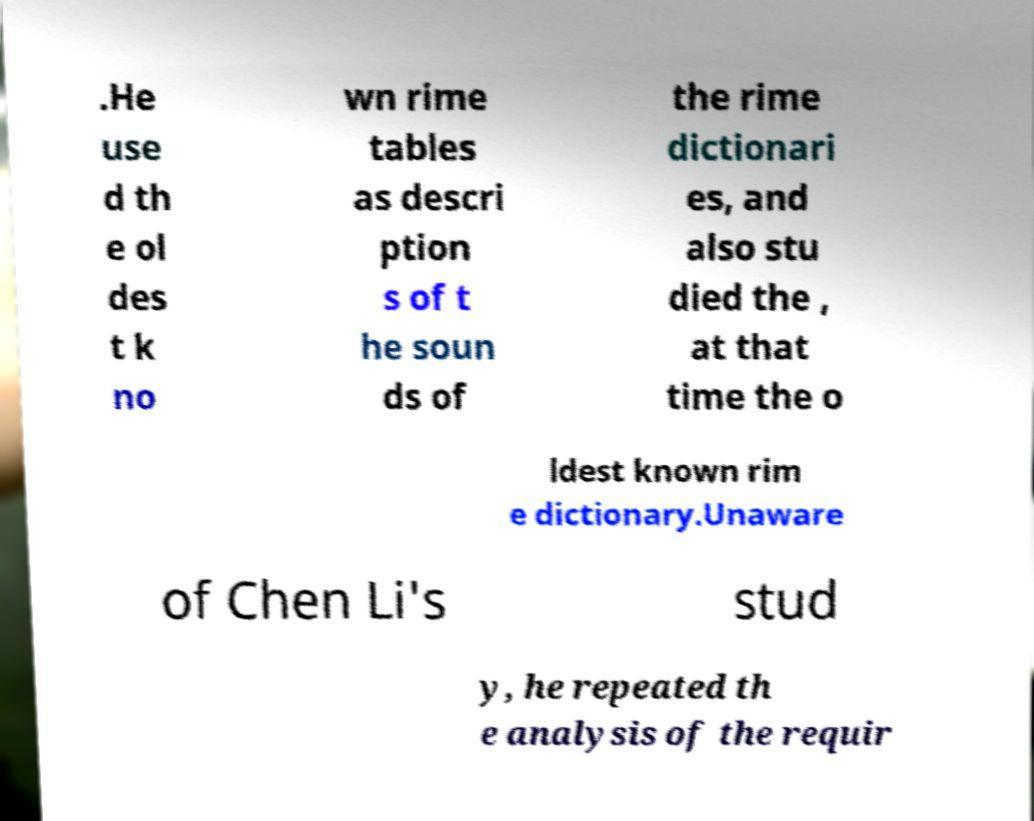Please read and relay the text visible in this image. What does it say? .He use d th e ol des t k no wn rime tables as descri ption s of t he soun ds of the rime dictionari es, and also stu died the , at that time the o ldest known rim e dictionary.Unaware of Chen Li's stud y, he repeated th e analysis of the requir 